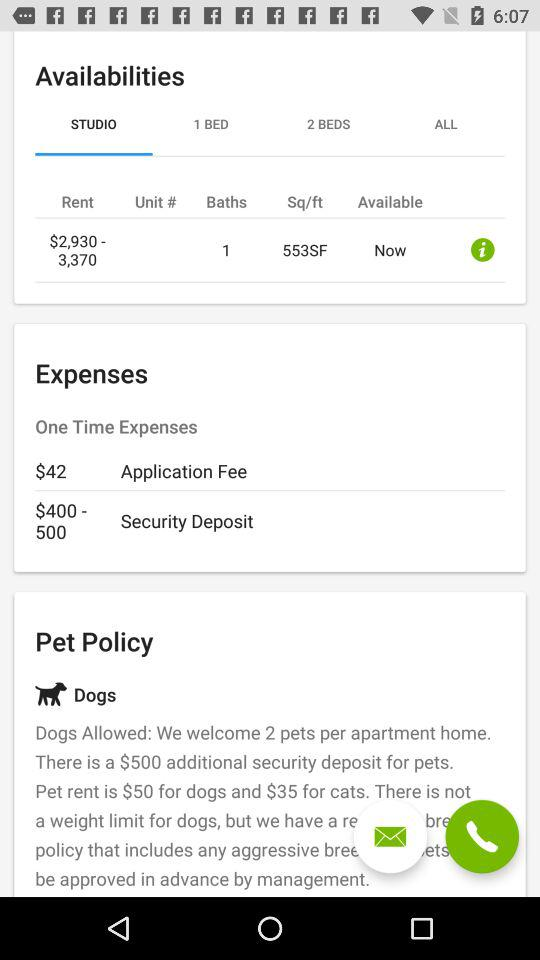What is the security deposit? The security deposit ranges from $400 to $500. 